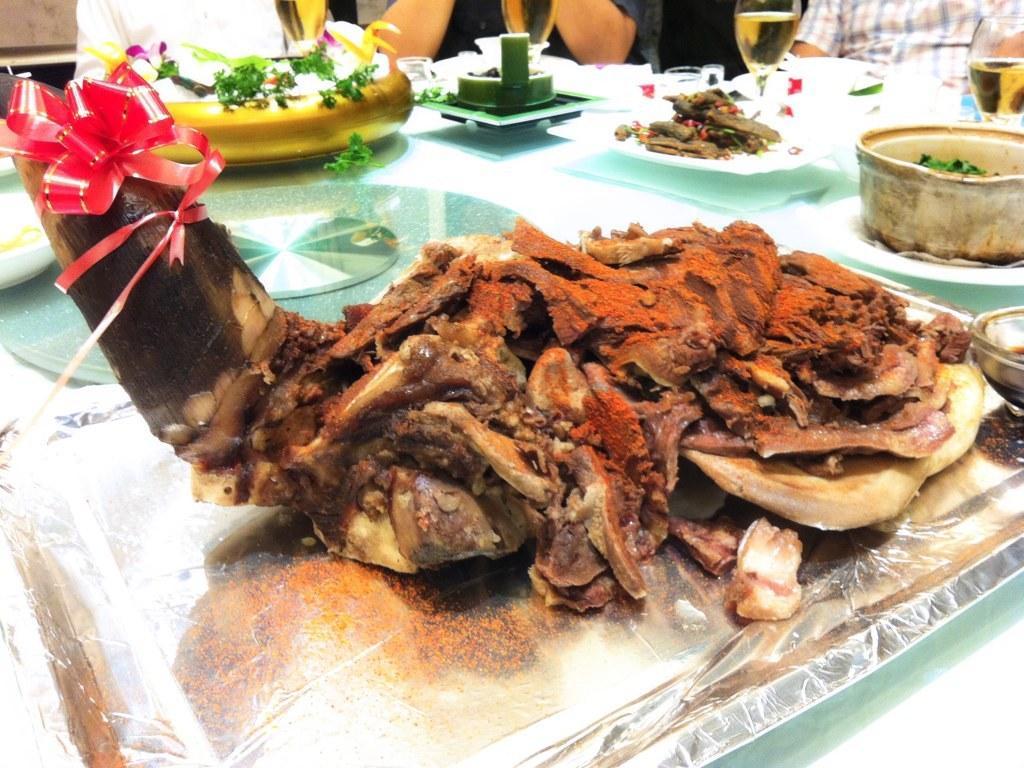Describe this image in one or two sentences. In this image I can see a table on which I can see few plates, a tray which is silver in color and on the tray I can see a food item which is black, brown, red and cream in color and I can see few bowls with food items in them. In the background I can see few persons sitting around the table. On the table I can see few wine glasses with liquid in them. 